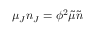Convert formula to latex. <formula><loc_0><loc_0><loc_500><loc_500>\mu _ { J } n _ { J } = \phi ^ { 2 } \tilde { \mu } \tilde { n }</formula> 